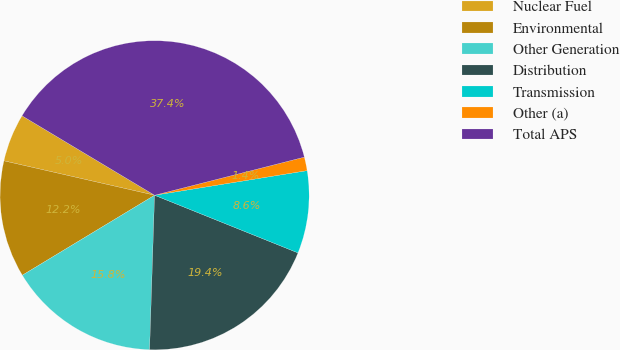Convert chart to OTSL. <chart><loc_0><loc_0><loc_500><loc_500><pie_chart><fcel>Nuclear Fuel<fcel>Environmental<fcel>Other Generation<fcel>Distribution<fcel>Transmission<fcel>Other (a)<fcel>Total APS<nl><fcel>5.02%<fcel>12.23%<fcel>15.83%<fcel>19.43%<fcel>8.63%<fcel>1.42%<fcel>37.44%<nl></chart> 